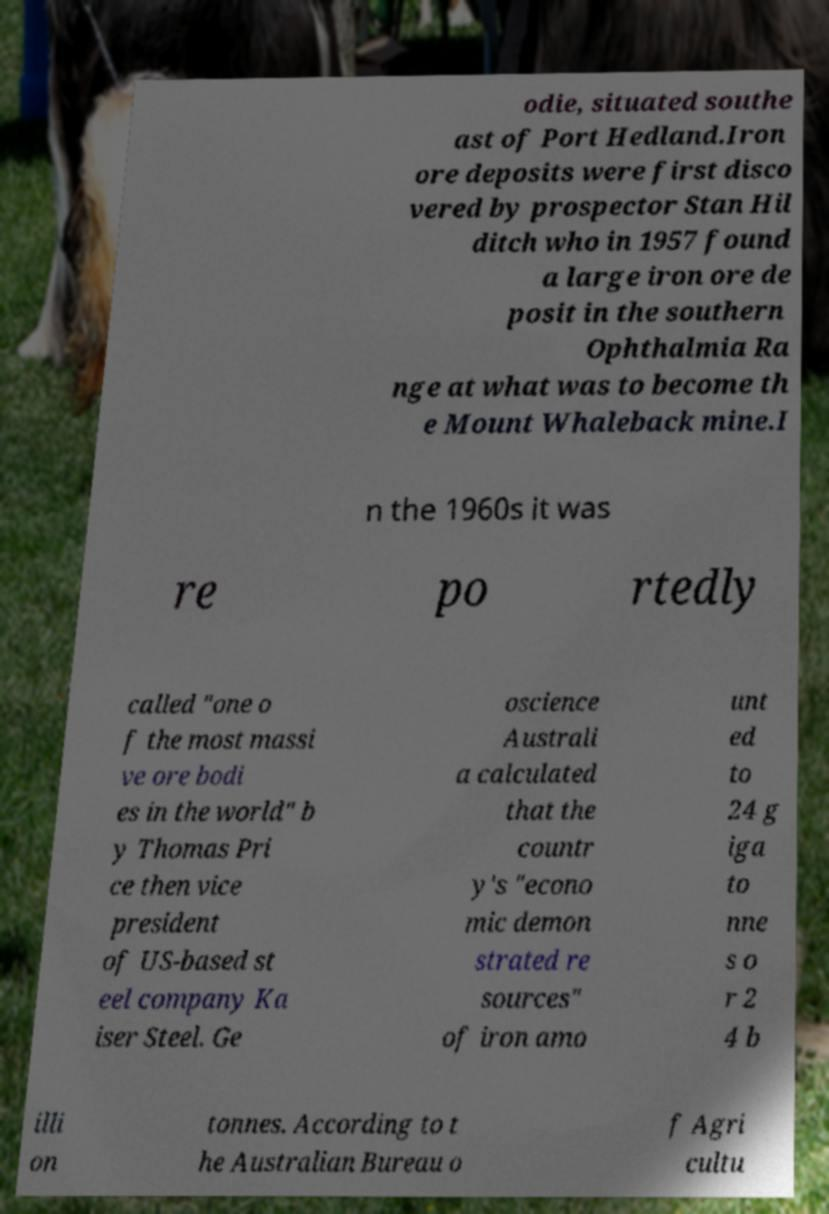Please read and relay the text visible in this image. What does it say? odie, situated southe ast of Port Hedland.Iron ore deposits were first disco vered by prospector Stan Hil ditch who in 1957 found a large iron ore de posit in the southern Ophthalmia Ra nge at what was to become th e Mount Whaleback mine.I n the 1960s it was re po rtedly called "one o f the most massi ve ore bodi es in the world" b y Thomas Pri ce then vice president of US-based st eel company Ka iser Steel. Ge oscience Australi a calculated that the countr y's "econo mic demon strated re sources" of iron amo unt ed to 24 g iga to nne s o r 2 4 b illi on tonnes. According to t he Australian Bureau o f Agri cultu 